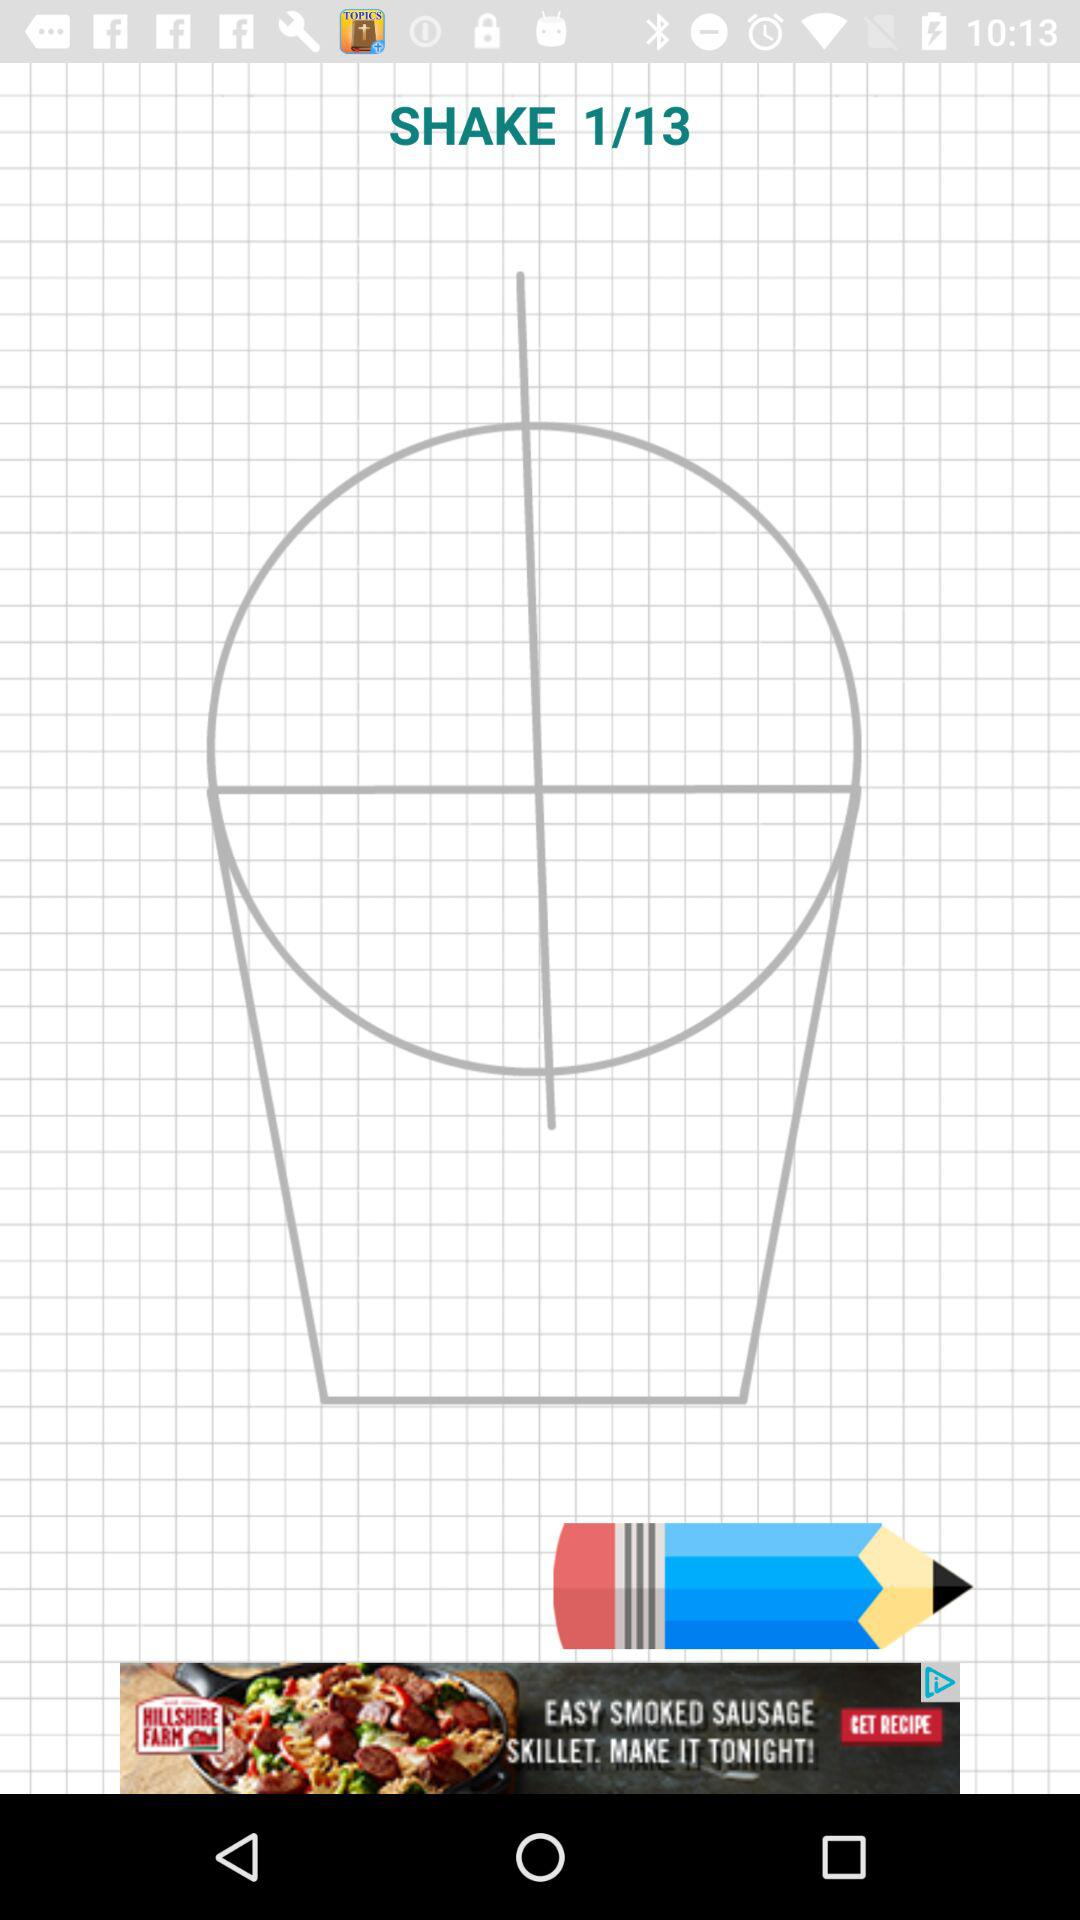At What image am I on? I am on image 1. 